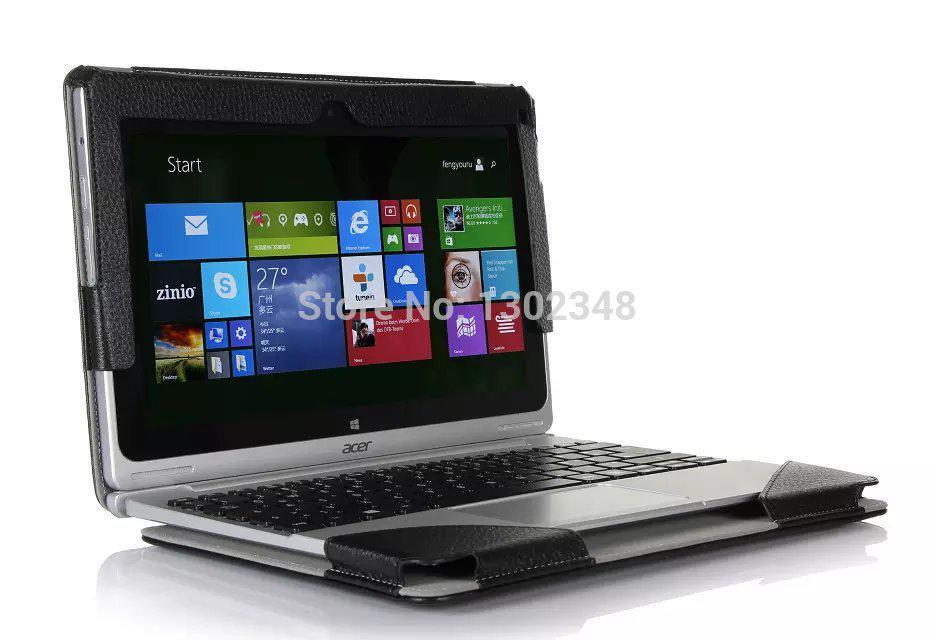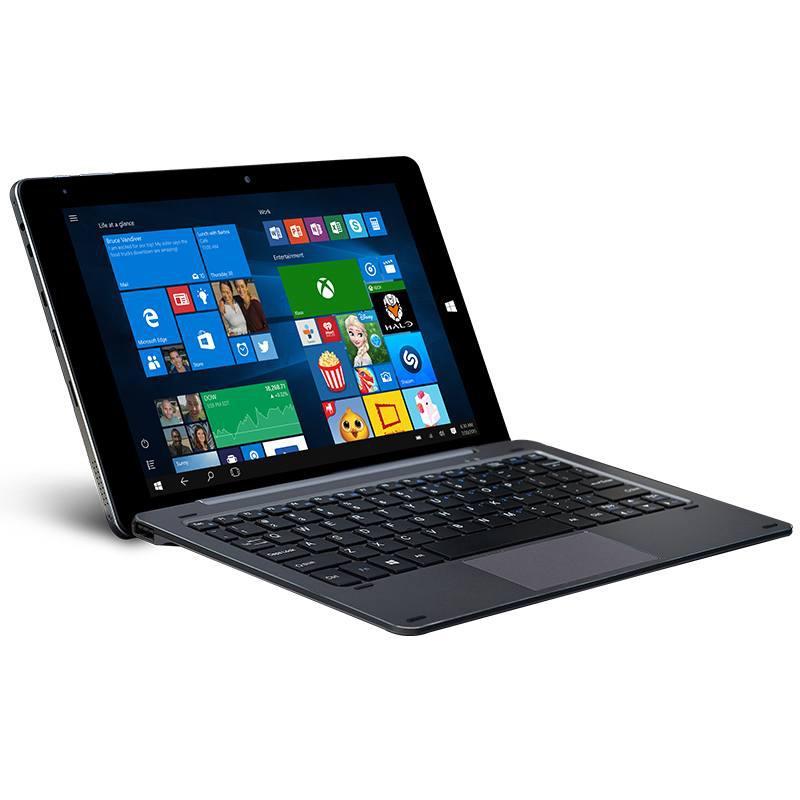The first image is the image on the left, the second image is the image on the right. For the images displayed, is the sentence "The left image shows a keyboard base separated from the screen, and the right image shows a device with multiple fanned out screens on top of an inverted V base." factually correct? Answer yes or no. No. The first image is the image on the left, the second image is the image on the right. Assess this claim about the two images: "The laptop in the image on the right is shown opening is several positions.". Correct or not? Answer yes or no. No. 